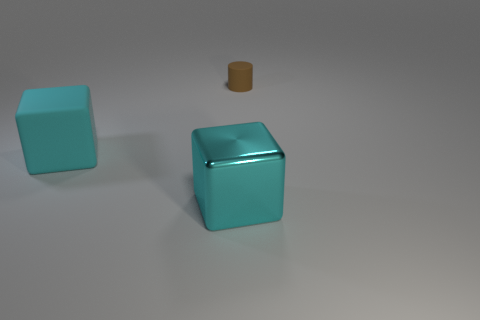There is a matte object on the left side of the big cyan shiny cube; how many brown things are on the left side of it?
Give a very brief answer. 0. There is a matte object that is in front of the brown rubber cylinder; is it the same shape as the matte object to the right of the metal block?
Make the answer very short. No. What number of small objects are on the left side of the large cyan matte cube?
Your answer should be compact. 0. Is the material of the big cyan block that is in front of the large rubber block the same as the tiny thing?
Offer a very short reply. No. What is the color of the metallic object that is the same shape as the large rubber thing?
Your answer should be compact. Cyan. What is the shape of the big cyan metallic object?
Ensure brevity in your answer.  Cube. What number of things are blue shiny things or brown cylinders?
Provide a succinct answer. 1. Is the color of the matte object that is left of the brown cylinder the same as the big thing in front of the big rubber object?
Ensure brevity in your answer.  Yes. How many other objects are there of the same shape as the tiny thing?
Your answer should be very brief. 0. Are any big cyan rubber blocks visible?
Offer a very short reply. Yes. 